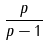<formula> <loc_0><loc_0><loc_500><loc_500>\frac { p } { p - 1 }</formula> 